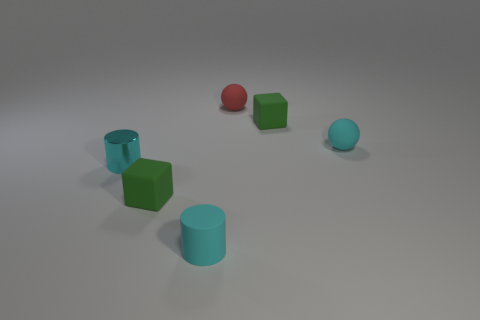Subtract all cyan spheres. How many spheres are left? 1 Add 4 cyan metal cylinders. How many objects exist? 10 Subtract all cyan blocks. Subtract all cyan cylinders. How many blocks are left? 2 Subtract all yellow balls. How many red cylinders are left? 0 Add 3 red objects. How many red objects exist? 4 Subtract 0 purple balls. How many objects are left? 6 Subtract all cylinders. How many objects are left? 4 Subtract 1 cylinders. How many cylinders are left? 1 Subtract all big green shiny spheres. Subtract all shiny things. How many objects are left? 5 Add 3 cyan things. How many cyan things are left? 6 